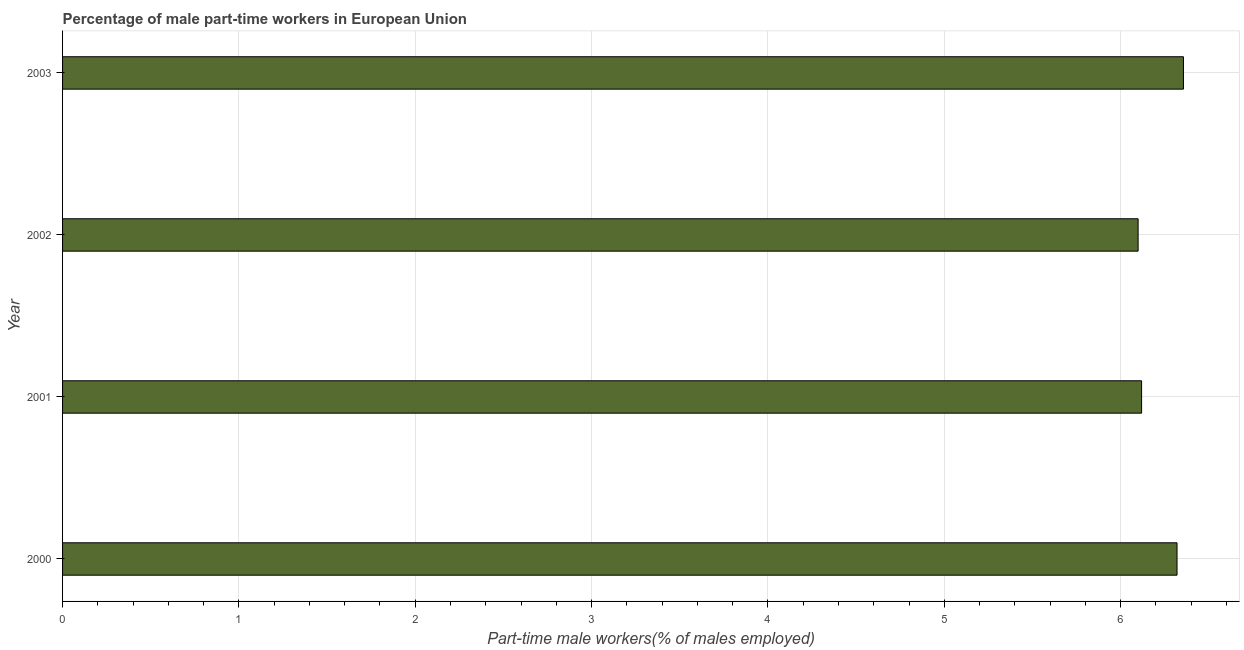Does the graph contain grids?
Make the answer very short. Yes. What is the title of the graph?
Give a very brief answer. Percentage of male part-time workers in European Union. What is the label or title of the X-axis?
Make the answer very short. Part-time male workers(% of males employed). What is the label or title of the Y-axis?
Your response must be concise. Year. What is the percentage of part-time male workers in 2000?
Offer a very short reply. 6.32. Across all years, what is the maximum percentage of part-time male workers?
Your answer should be very brief. 6.36. Across all years, what is the minimum percentage of part-time male workers?
Ensure brevity in your answer.  6.1. In which year was the percentage of part-time male workers maximum?
Provide a succinct answer. 2003. In which year was the percentage of part-time male workers minimum?
Your answer should be compact. 2002. What is the sum of the percentage of part-time male workers?
Provide a succinct answer. 24.89. What is the difference between the percentage of part-time male workers in 2002 and 2003?
Your answer should be very brief. -0.26. What is the average percentage of part-time male workers per year?
Make the answer very short. 6.22. What is the median percentage of part-time male workers?
Give a very brief answer. 6.22. In how many years, is the percentage of part-time male workers greater than 6 %?
Your answer should be compact. 4. What is the difference between the highest and the second highest percentage of part-time male workers?
Give a very brief answer. 0.04. Is the sum of the percentage of part-time male workers in 2000 and 2003 greater than the maximum percentage of part-time male workers across all years?
Offer a very short reply. Yes. What is the difference between the highest and the lowest percentage of part-time male workers?
Offer a very short reply. 0.26. In how many years, is the percentage of part-time male workers greater than the average percentage of part-time male workers taken over all years?
Keep it short and to the point. 2. How many bars are there?
Offer a terse response. 4. Are all the bars in the graph horizontal?
Keep it short and to the point. Yes. How many years are there in the graph?
Provide a succinct answer. 4. What is the difference between two consecutive major ticks on the X-axis?
Your answer should be compact. 1. What is the Part-time male workers(% of males employed) of 2000?
Provide a short and direct response. 6.32. What is the Part-time male workers(% of males employed) in 2001?
Offer a very short reply. 6.12. What is the Part-time male workers(% of males employed) of 2002?
Provide a short and direct response. 6.1. What is the Part-time male workers(% of males employed) of 2003?
Your answer should be compact. 6.36. What is the difference between the Part-time male workers(% of males employed) in 2000 and 2001?
Your answer should be very brief. 0.2. What is the difference between the Part-time male workers(% of males employed) in 2000 and 2002?
Your answer should be very brief. 0.22. What is the difference between the Part-time male workers(% of males employed) in 2000 and 2003?
Ensure brevity in your answer.  -0.04. What is the difference between the Part-time male workers(% of males employed) in 2001 and 2002?
Your answer should be very brief. 0.02. What is the difference between the Part-time male workers(% of males employed) in 2001 and 2003?
Give a very brief answer. -0.24. What is the difference between the Part-time male workers(% of males employed) in 2002 and 2003?
Make the answer very short. -0.26. What is the ratio of the Part-time male workers(% of males employed) in 2000 to that in 2001?
Provide a succinct answer. 1.03. What is the ratio of the Part-time male workers(% of males employed) in 2000 to that in 2002?
Keep it short and to the point. 1.04. What is the ratio of the Part-time male workers(% of males employed) in 2000 to that in 2003?
Make the answer very short. 0.99. What is the ratio of the Part-time male workers(% of males employed) in 2001 to that in 2002?
Offer a very short reply. 1. What is the ratio of the Part-time male workers(% of males employed) in 2002 to that in 2003?
Keep it short and to the point. 0.96. 